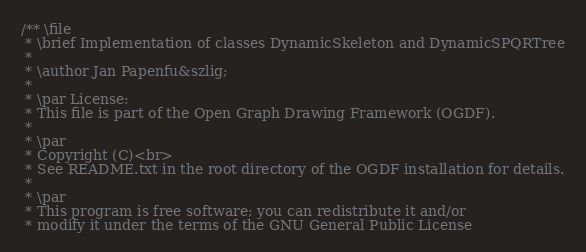Convert code to text. <code><loc_0><loc_0><loc_500><loc_500><_C++_>/** \file
 * \brief Implementation of classes DynamicSkeleton and DynamicSPQRTree
 *
 * \author Jan Papenfu&szlig;
 *
 * \par License:
 * This file is part of the Open Graph Drawing Framework (OGDF).
 *
 * \par
 * Copyright (C)<br>
 * See README.txt in the root directory of the OGDF installation for details.
 *
 * \par
 * This program is free software; you can redistribute it and/or
 * modify it under the terms of the GNU General Public License</code> 